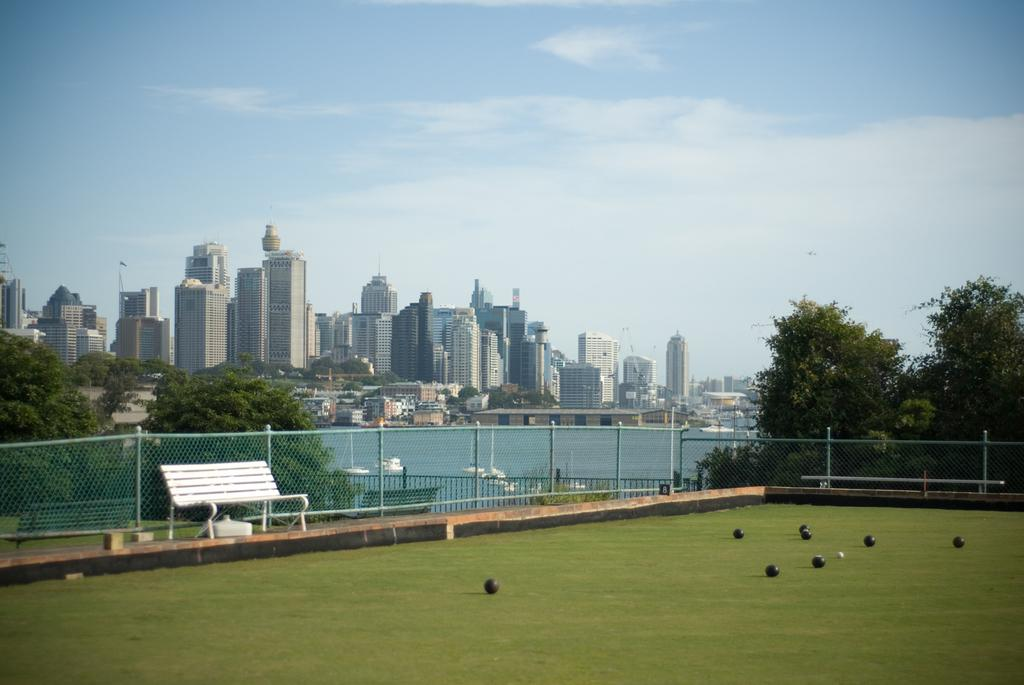What type of seating is present in the image? There is a bench in the image. What objects are on the ground in the image? There are balls on the ground in the image. What type of structures can be seen in the image? There are buildings visible in the image. What type of barrier is present in the image? There is fencing in the image. What type of vegetation is present in the image? There are trees in the image. What type of body of water is present in the image? There is a lake in the image. What type of pencil can be seen in the image? There is no pencil present in the image. What is the angle of the bench in the image? The angle of the bench cannot be determined from the image alone, as it is a two-dimensional representation. What is the size of the lake in the image? The size of the lake cannot be determined from the image alone, as it is a two-dimensional representation. 